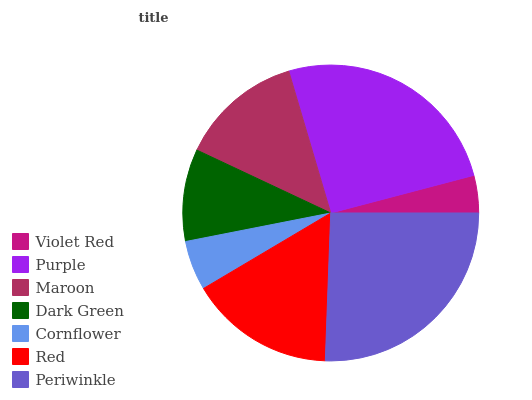Is Violet Red the minimum?
Answer yes or no. Yes. Is Periwinkle the maximum?
Answer yes or no. Yes. Is Purple the minimum?
Answer yes or no. No. Is Purple the maximum?
Answer yes or no. No. Is Purple greater than Violet Red?
Answer yes or no. Yes. Is Violet Red less than Purple?
Answer yes or no. Yes. Is Violet Red greater than Purple?
Answer yes or no. No. Is Purple less than Violet Red?
Answer yes or no. No. Is Maroon the high median?
Answer yes or no. Yes. Is Maroon the low median?
Answer yes or no. Yes. Is Cornflower the high median?
Answer yes or no. No. Is Red the low median?
Answer yes or no. No. 